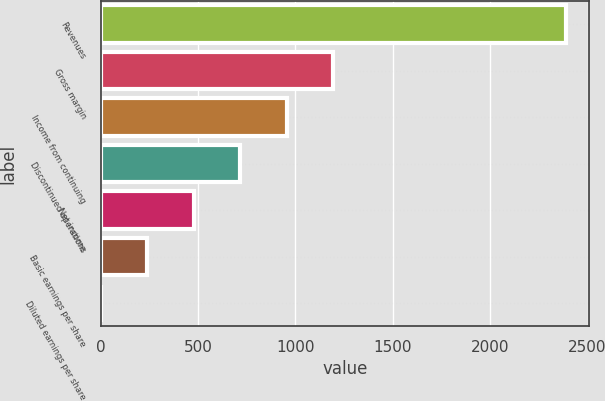<chart> <loc_0><loc_0><loc_500><loc_500><bar_chart><fcel>Revenues<fcel>Gross margin<fcel>Income from continuing<fcel>Discontinued operations<fcel>Net income<fcel>Basic earnings per share<fcel>Diluted earnings per share<nl><fcel>2387<fcel>1193.53<fcel>954.84<fcel>716.15<fcel>477.46<fcel>238.77<fcel>0.08<nl></chart> 